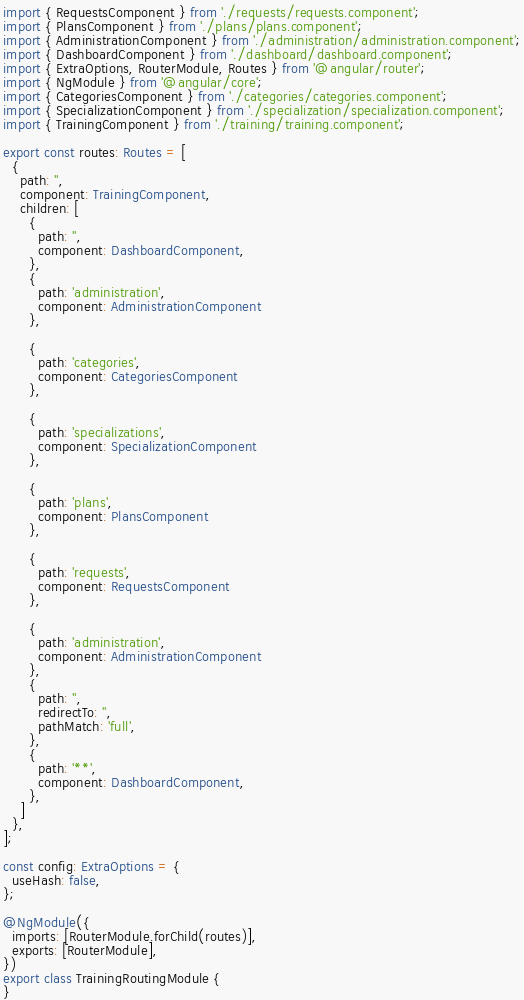<code> <loc_0><loc_0><loc_500><loc_500><_TypeScript_>import { RequestsComponent } from './requests/requests.component';
import { PlansComponent } from './plans/plans.component';
import { AdministrationComponent } from './administration/administration.component';
import { DashboardComponent } from './dashboard/dashboard.component';
import { ExtraOptions, RouterModule, Routes } from '@angular/router';
import { NgModule } from '@angular/core';
import { CategoriesComponent } from './categories/categories.component';
import { SpecializationComponent } from './specialization/specialization.component';
import { TrainingComponent } from './training/training.component';

export const routes: Routes = [
  {
    path: '',
    component: TrainingComponent,
    children: [
      {
        path: '',
        component: DashboardComponent,
      },
      {
        path: 'administration',
        component: AdministrationComponent
      },

      {
        path: 'categories',
        component: CategoriesComponent
      },

      {
        path: 'specializations',
        component: SpecializationComponent
      },

      {
        path: 'plans',
        component: PlansComponent
      },

      {
        path: 'requests',
        component: RequestsComponent
      },

      {
        path: 'administration',
        component: AdministrationComponent
      },
      {
        path: '',
        redirectTo: '',
        pathMatch: 'full',
      },
      {
        path: '**',
        component: DashboardComponent,
      },
    ]
  },
];

const config: ExtraOptions = {
  useHash: false,
};

@NgModule({
  imports: [RouterModule.forChild(routes)],
  exports: [RouterModule],
})
export class TrainingRoutingModule {
}
</code> 